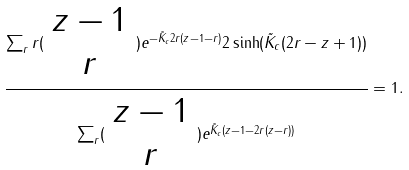Convert formula to latex. <formula><loc_0><loc_0><loc_500><loc_500>\frac { \sum _ { r } r ( \begin{array} { c } z - 1 \\ r \\ \end{array} ) e ^ { - \tilde { K } _ { c } 2 r ( z - 1 - r ) } 2 \sinh ( \tilde { K } _ { c } ( 2 r - z + 1 ) ) } { \sum _ { r } ( \begin{array} { c } z - 1 \\ r \\ \end{array} ) e ^ { \tilde { K } _ { c } ( z - 1 - 2 r ( z - r ) ) } } = 1 .</formula> 